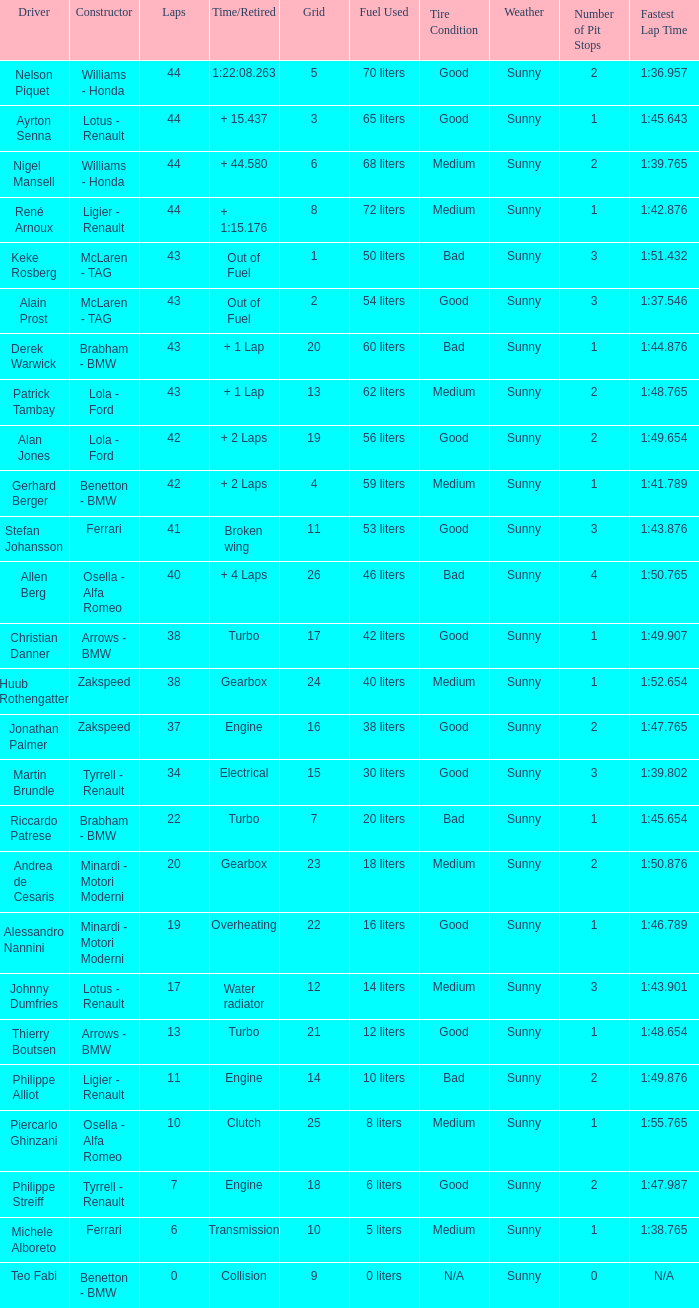I want the driver that has Laps of 10 Piercarlo Ghinzani. 